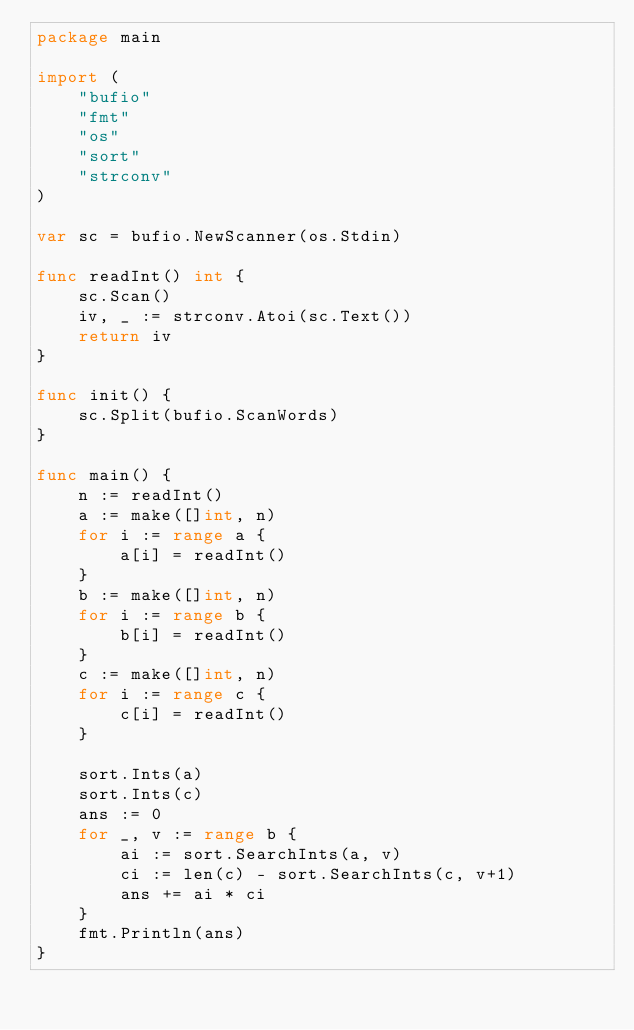<code> <loc_0><loc_0><loc_500><loc_500><_Go_>package main

import (
	"bufio"
	"fmt"
	"os"
	"sort"
	"strconv"
)

var sc = bufio.NewScanner(os.Stdin)

func readInt() int {
	sc.Scan()
	iv, _ := strconv.Atoi(sc.Text())
	return iv
}

func init() {
	sc.Split(bufio.ScanWords)
}

func main() {
	n := readInt()
	a := make([]int, n)
	for i := range a {
		a[i] = readInt()
	}
	b := make([]int, n)
	for i := range b {
		b[i] = readInt()
	}
	c := make([]int, n)
	for i := range c {
		c[i] = readInt()
	}

	sort.Ints(a)
	sort.Ints(c)
	ans := 0
	for _, v := range b {
		ai := sort.SearchInts(a, v)
		ci := len(c) - sort.SearchInts(c, v+1)
		ans += ai * ci
	}
	fmt.Println(ans)
}
</code> 